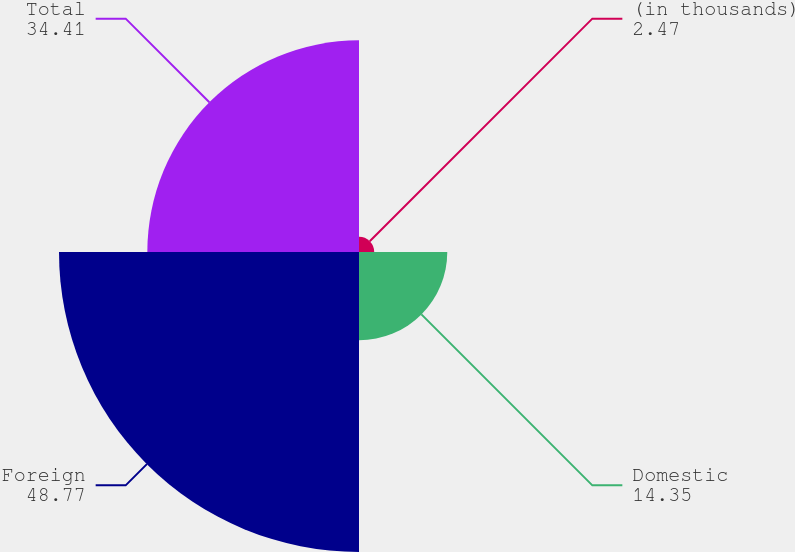Convert chart to OTSL. <chart><loc_0><loc_0><loc_500><loc_500><pie_chart><fcel>(in thousands)<fcel>Domestic<fcel>Foreign<fcel>Total<nl><fcel>2.47%<fcel>14.35%<fcel>48.77%<fcel>34.41%<nl></chart> 